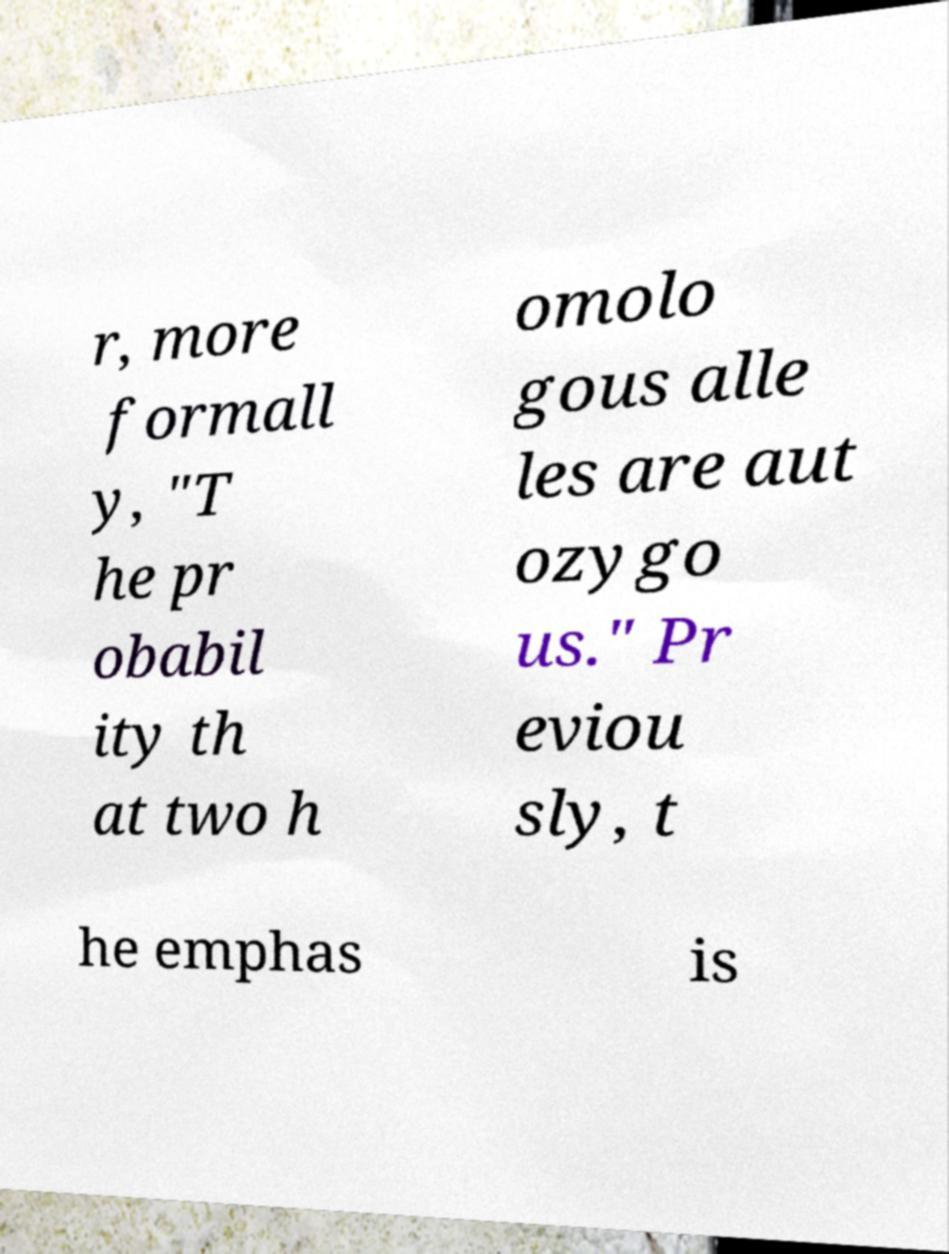Can you read and provide the text displayed in the image?This photo seems to have some interesting text. Can you extract and type it out for me? r, more formall y, "T he pr obabil ity th at two h omolo gous alle les are aut ozygo us." Pr eviou sly, t he emphas is 